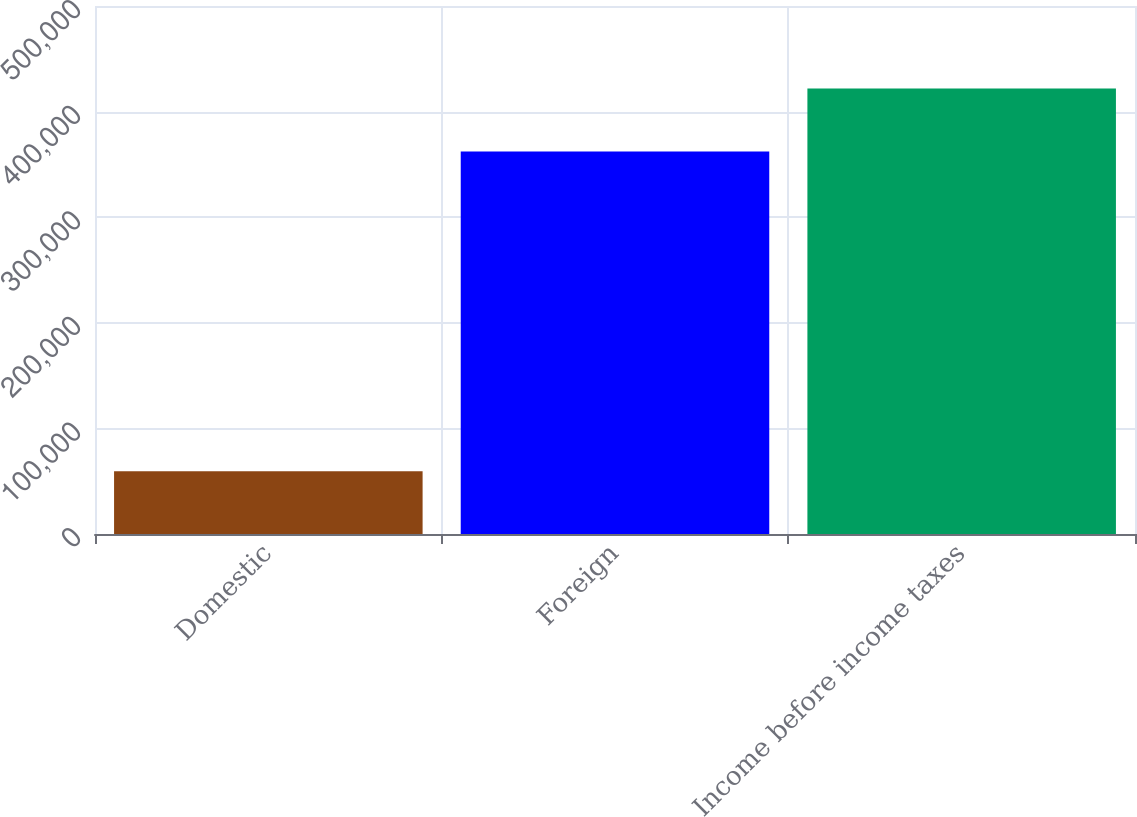<chart> <loc_0><loc_0><loc_500><loc_500><bar_chart><fcel>Domestic<fcel>Foreign<fcel>Income before income taxes<nl><fcel>59473<fcel>362292<fcel>421765<nl></chart> 